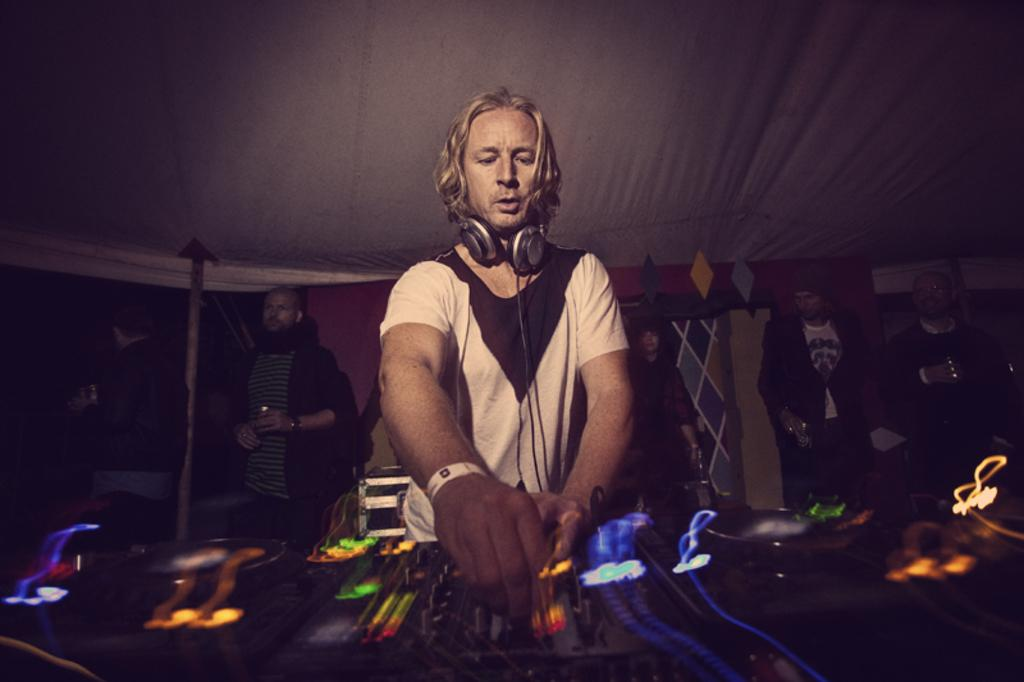What is the man in the image doing? The man is standing in the image. What can be seen on the man's head? The man is wearing a wired headset. What is in front of the man? There is an electrical device in front of the man. What can be seen in the background of the image? There are people and a tent in the background of the image. What type of kettle is being used to shake the credit in the image? There is no kettle or credit present in the image. 